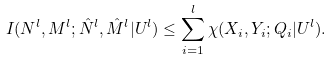<formula> <loc_0><loc_0><loc_500><loc_500>I ( N ^ { l } , M ^ { l } ; \hat { N } ^ { l } , \hat { M } ^ { l } | U ^ { l } ) & \leq \sum _ { i = 1 } ^ { l } \chi ( X _ { i } , Y _ { i } ; Q _ { i } | U ^ { l } ) .</formula> 